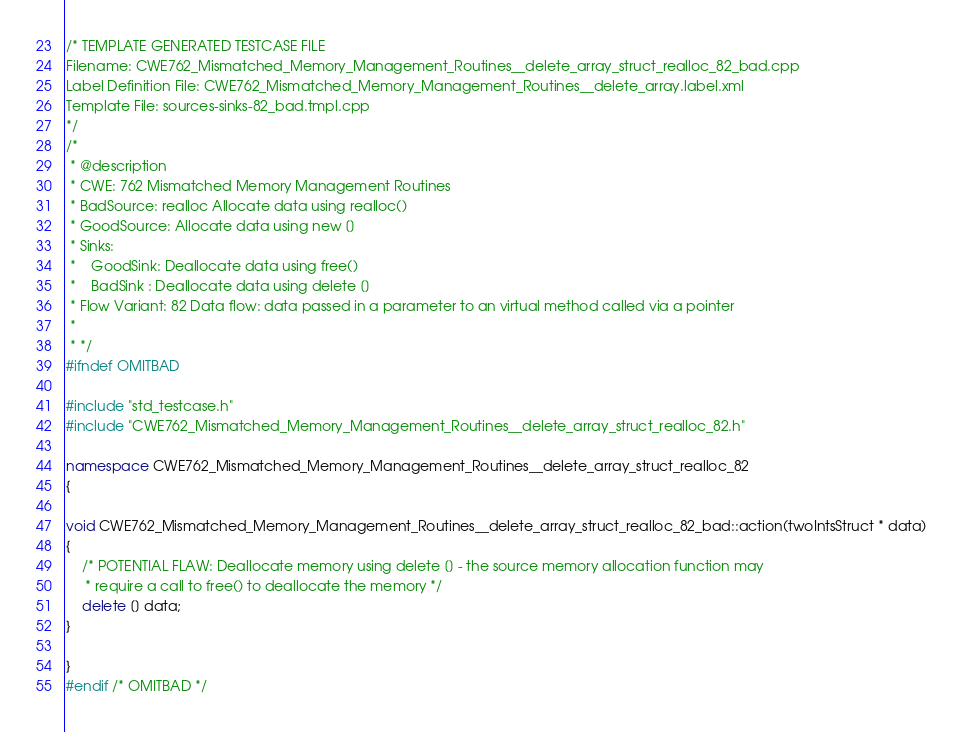Convert code to text. <code><loc_0><loc_0><loc_500><loc_500><_C++_>/* TEMPLATE GENERATED TESTCASE FILE
Filename: CWE762_Mismatched_Memory_Management_Routines__delete_array_struct_realloc_82_bad.cpp
Label Definition File: CWE762_Mismatched_Memory_Management_Routines__delete_array.label.xml
Template File: sources-sinks-82_bad.tmpl.cpp
*/
/*
 * @description
 * CWE: 762 Mismatched Memory Management Routines
 * BadSource: realloc Allocate data using realloc()
 * GoodSource: Allocate data using new []
 * Sinks:
 *    GoodSink: Deallocate data using free()
 *    BadSink : Deallocate data using delete []
 * Flow Variant: 82 Data flow: data passed in a parameter to an virtual method called via a pointer
 *
 * */
#ifndef OMITBAD

#include "std_testcase.h"
#include "CWE762_Mismatched_Memory_Management_Routines__delete_array_struct_realloc_82.h"

namespace CWE762_Mismatched_Memory_Management_Routines__delete_array_struct_realloc_82
{

void CWE762_Mismatched_Memory_Management_Routines__delete_array_struct_realloc_82_bad::action(twoIntsStruct * data)
{
    /* POTENTIAL FLAW: Deallocate memory using delete [] - the source memory allocation function may
     * require a call to free() to deallocate the memory */
    delete [] data;
}

}
#endif /* OMITBAD */
</code> 